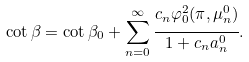<formula> <loc_0><loc_0><loc_500><loc_500>\cot \beta = \cot \beta _ { 0 } + \sum _ { n = 0 } ^ { \infty } \cfrac { c _ { n } \varphi _ { 0 } ^ { 2 } ( \pi , \mu _ { n } ^ { 0 } ) } { 1 + c _ { n } a _ { n } ^ { 0 } } .</formula> 